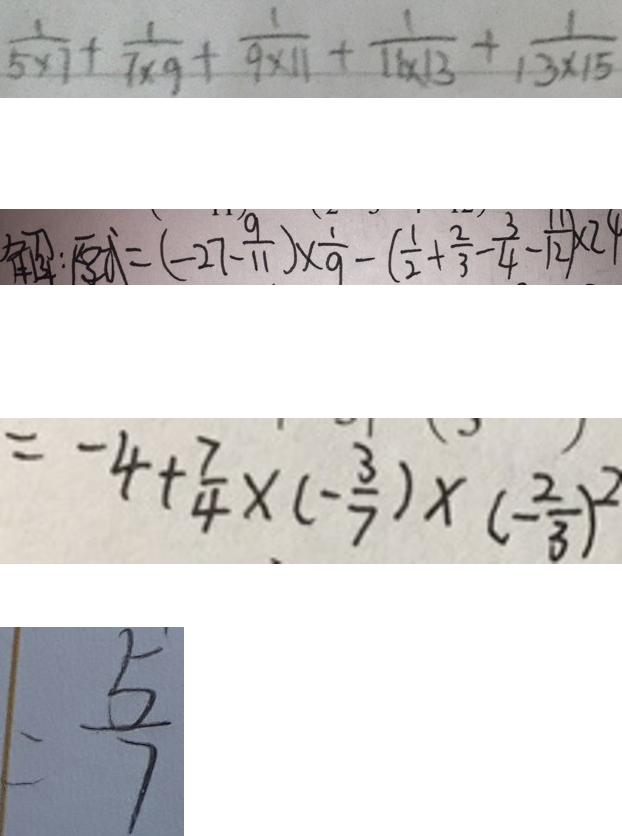Convert formula to latex. <formula><loc_0><loc_0><loc_500><loc_500>\frac { 1 } { 5 \times 7 } + \frac { 1 } { 7 \times 9 } + \frac { 1 } { 9 \times 1 1 } + \frac { 1 } { 1 1 \times 1 3 } + \frac { 1 } { 1 3 \times 1 5 } 
 解 : 原 式 = ( - 2 7 - \frac { 9 } { 1 1 } ) \times \frac { 1 } { 9 } - ( \frac { 1 } { 2 } + \frac { 2 } { 3 } - \frac { 3 } { 4 } - \frac { 1 1 } { 1 2 } ) \times 2 4 
 = - 4 + \frac { 7 } { 4 } \times ( - \frac { 3 } { 7 } ) \times ( - \frac { 2 } { 3 } ) ^ { 2 } 
 = \frac { 5 } { 7 }</formula> 